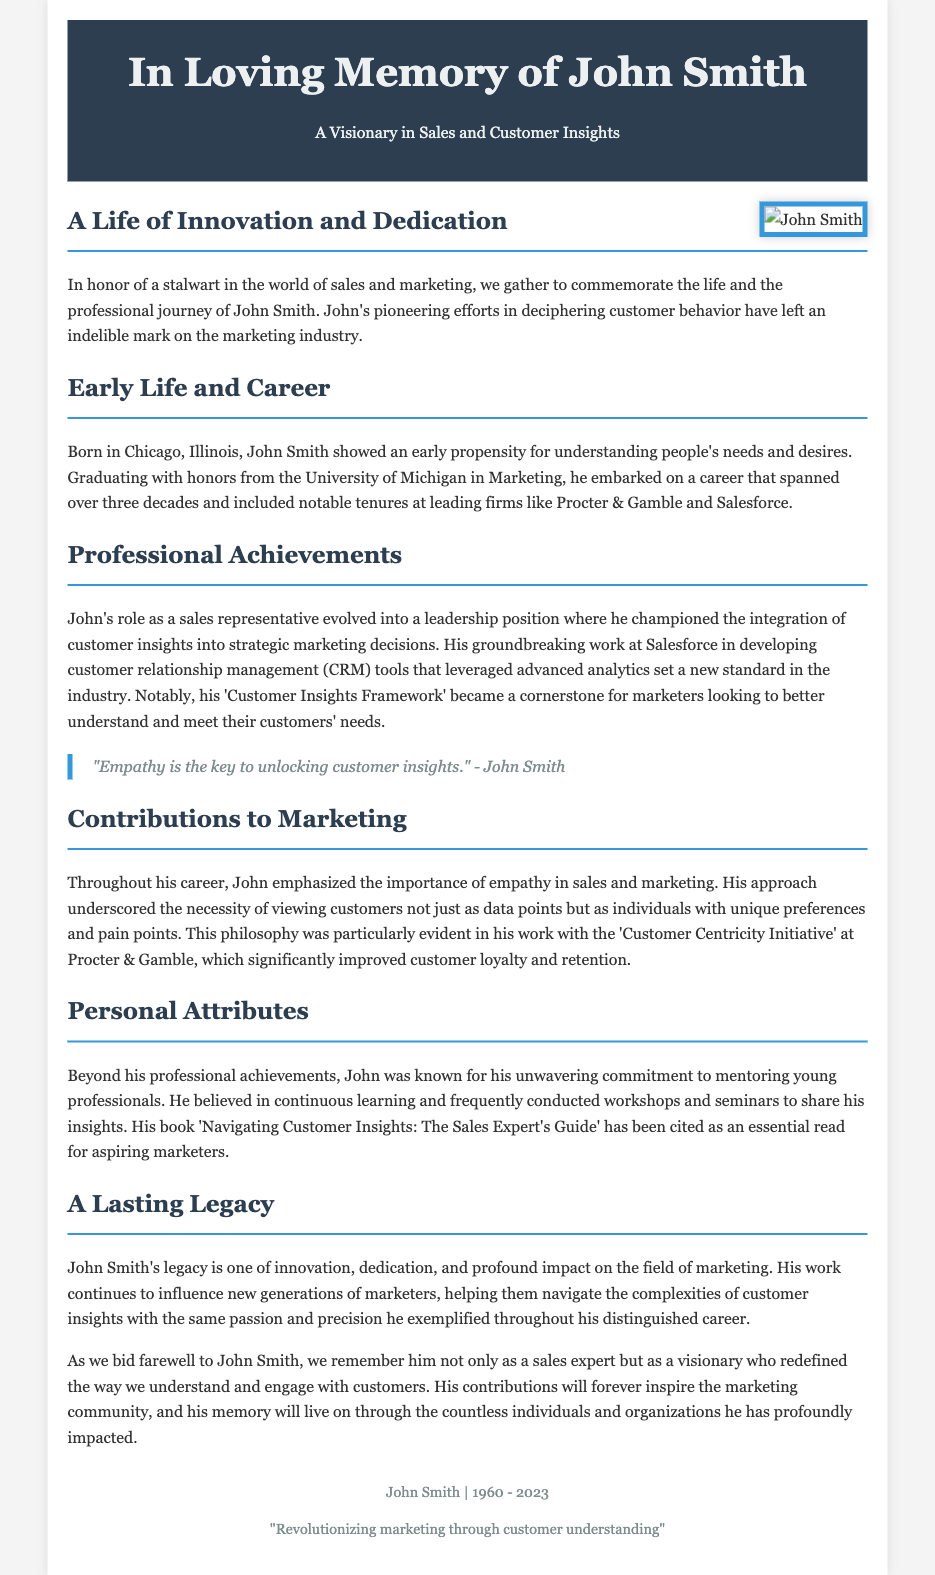What is the name of the sales expert being honored? The document explicitly states that John Smith is the individual being commemorated.
Answer: John Smith What year was John Smith born? The document provides the information that John Smith was born in the year 1960.
Answer: 1960 What was John Smith's role at Salesforce? The document mentions that he developed customer relationship management tools at Salesforce.
Answer: Developing CRM tools What key philosophy did John Smith emphasize in marketing? The document highlights that he emphasized empathy in sales and marketing.
Answer: Empathy What is the title of John Smith's book? The document states that his book is titled 'Navigating Customer Insights: The Sales Expert's Guide.'
Answer: Navigating Customer Insights: The Sales Expert's Guide In how many decades did John Smith's career span? The document notes that his career spanned over three decades.
Answer: Three decades What initiative did John Smith work on at Procter & Gamble? The document specifies that he was involved with the 'Customer Centricity Initiative' at Procter & Gamble.
Answer: Customer Centricity Initiative What was John Smith's contribution to the marketing community? The document states that his work continues to influence new generations of marketers.
Answer: Influencing new generations 